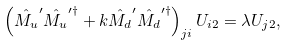<formula> <loc_0><loc_0><loc_500><loc_500>\left ( \hat { M _ { u } } ^ { \prime } \hat { M _ { u } } ^ { \prime \dagger } + k \hat { M _ { d } } ^ { \prime } \hat { M _ { d } } ^ { \prime \dagger } \right ) _ { j i } U _ { i 2 } = \lambda U _ { j 2 } ,</formula> 